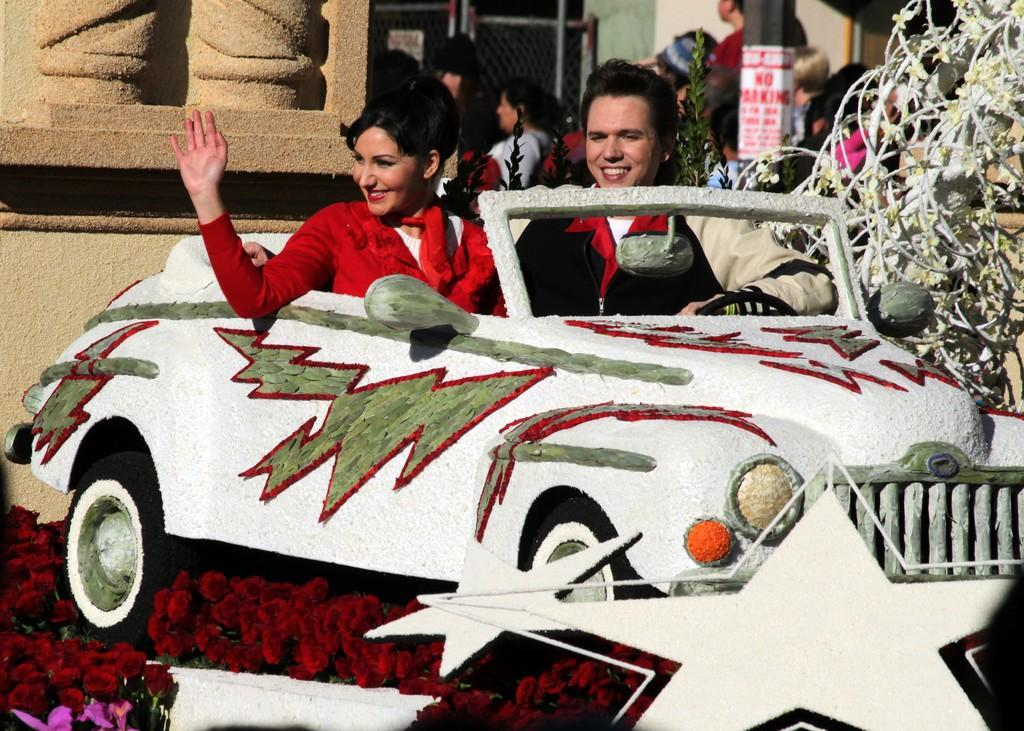How many people are present in the image? There are two people in the image, a man and a woman. What are the man and woman doing in the image? Both the man and woman are sitting in a vehicle. Can you describe the background of the image? There are people visible in the background of the image. What emotion can be observed on some of the faces in the image? Some faces in the image have a smile. What type of beds can be seen in the aftermath of the accident in the image? There is no accident or beds present in the image; it features a man and a woman sitting in a vehicle with people in the background. 